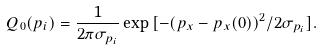Convert formula to latex. <formula><loc_0><loc_0><loc_500><loc_500>Q _ { 0 } ( p _ { i } ) = \frac { 1 } { 2 \pi \sigma _ { p _ { i } } } \exp { [ - { ( p _ { x } - p _ { x } ( 0 ) ) ^ { 2 } } / { 2 \sigma _ { p _ { i } } ] } } .</formula> 